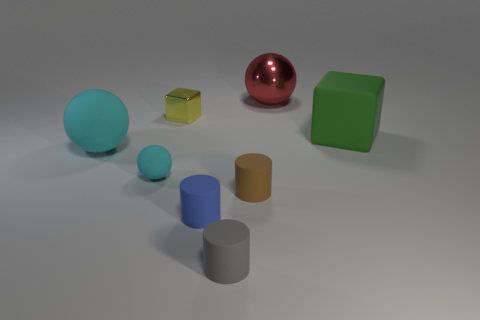The green thing that is made of the same material as the blue thing is what size?
Make the answer very short. Large. There is a sphere that is behind the green matte thing that is right of the cyan matte sphere left of the small cyan sphere; what is its size?
Your response must be concise. Large. There is a big ball in front of the big cube; what color is it?
Keep it short and to the point. Cyan. Are there more small cyan rubber spheres left of the small blue matte cylinder than gray metal blocks?
Make the answer very short. Yes. There is a small object in front of the tiny blue matte cylinder; is its shape the same as the tiny yellow thing?
Provide a short and direct response. No. What number of yellow things are either cylinders or cubes?
Offer a terse response. 1. Is the number of yellow cubes greater than the number of tiny matte objects?
Your answer should be compact. No. There is a ball that is the same size as the yellow metallic thing; what is its color?
Your response must be concise. Cyan. What number of cylinders are small gray matte things or cyan things?
Give a very brief answer. 1. There is a blue thing; is it the same shape as the big matte object that is left of the blue cylinder?
Your answer should be compact. No. 